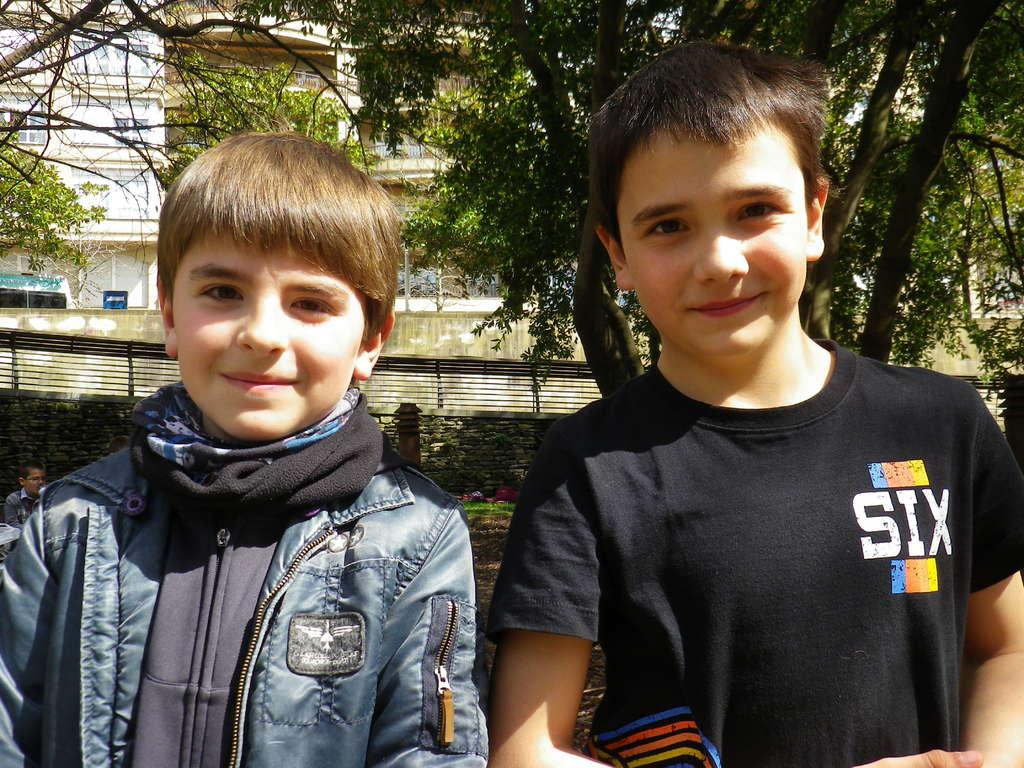How many boys are present in the image? There are two boys standing in the image. What is the facial expression of the boys? The boys are smiling. Can you describe the person behind the boys? There is another person behind the boys, but their appearance is not specified in the facts. What can be seen in the background of the image? Trees, a wall, and a building are visible in the background of the image. What type of thumb is visible in the image? There is no thumb present in the image. How many bites can be seen on the apple in the image? There is no apple or bite marks visible in the image. 